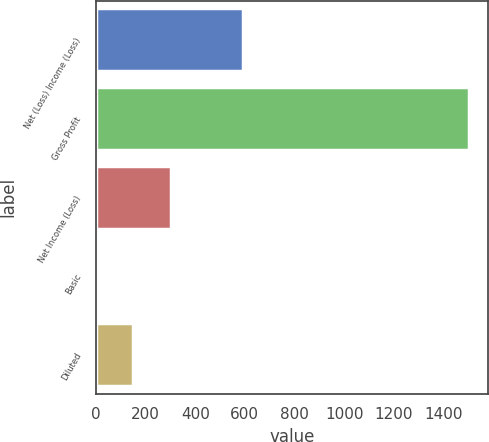Convert chart. <chart><loc_0><loc_0><loc_500><loc_500><bar_chart><fcel>Net (Loss) Income (Loss)<fcel>Gross Profit<fcel>Net Income (Loss)<fcel>Basic<fcel>Diluted<nl><fcel>594<fcel>1504<fcel>301.41<fcel>0.75<fcel>151.08<nl></chart> 